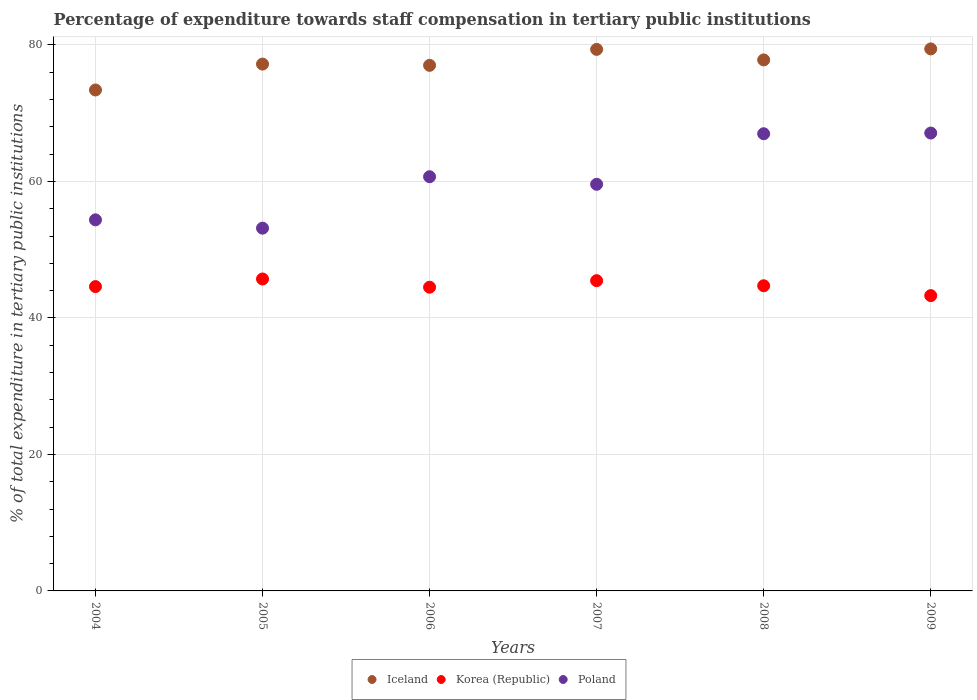How many different coloured dotlines are there?
Make the answer very short. 3. What is the percentage of expenditure towards staff compensation in Korea (Republic) in 2006?
Make the answer very short. 44.5. Across all years, what is the maximum percentage of expenditure towards staff compensation in Poland?
Give a very brief answer. 67.09. Across all years, what is the minimum percentage of expenditure towards staff compensation in Poland?
Your response must be concise. 53.15. In which year was the percentage of expenditure towards staff compensation in Korea (Republic) minimum?
Provide a succinct answer. 2009. What is the total percentage of expenditure towards staff compensation in Korea (Republic) in the graph?
Make the answer very short. 268.24. What is the difference between the percentage of expenditure towards staff compensation in Poland in 2005 and that in 2007?
Provide a short and direct response. -6.43. What is the difference between the percentage of expenditure towards staff compensation in Korea (Republic) in 2005 and the percentage of expenditure towards staff compensation in Poland in 2007?
Your answer should be very brief. -13.88. What is the average percentage of expenditure towards staff compensation in Poland per year?
Provide a short and direct response. 60.31. In the year 2009, what is the difference between the percentage of expenditure towards staff compensation in Iceland and percentage of expenditure towards staff compensation in Korea (Republic)?
Offer a very short reply. 36.15. What is the ratio of the percentage of expenditure towards staff compensation in Iceland in 2004 to that in 2007?
Provide a short and direct response. 0.93. What is the difference between the highest and the second highest percentage of expenditure towards staff compensation in Poland?
Offer a terse response. 0.1. What is the difference between the highest and the lowest percentage of expenditure towards staff compensation in Korea (Republic)?
Your answer should be very brief. 2.44. Is the percentage of expenditure towards staff compensation in Poland strictly greater than the percentage of expenditure towards staff compensation in Iceland over the years?
Provide a short and direct response. No. What is the difference between two consecutive major ticks on the Y-axis?
Offer a terse response. 20. Are the values on the major ticks of Y-axis written in scientific E-notation?
Your answer should be compact. No. Does the graph contain any zero values?
Provide a short and direct response. No. How are the legend labels stacked?
Give a very brief answer. Horizontal. What is the title of the graph?
Your response must be concise. Percentage of expenditure towards staff compensation in tertiary public institutions. Does "Slovenia" appear as one of the legend labels in the graph?
Your answer should be compact. No. What is the label or title of the X-axis?
Provide a short and direct response. Years. What is the label or title of the Y-axis?
Keep it short and to the point. % of total expenditure in tertiary public institutions. What is the % of total expenditure in tertiary public institutions of Iceland in 2004?
Give a very brief answer. 73.4. What is the % of total expenditure in tertiary public institutions in Korea (Republic) in 2004?
Make the answer very short. 44.59. What is the % of total expenditure in tertiary public institutions of Poland in 2004?
Give a very brief answer. 54.37. What is the % of total expenditure in tertiary public institutions of Iceland in 2005?
Offer a very short reply. 77.19. What is the % of total expenditure in tertiary public institutions of Korea (Republic) in 2005?
Provide a succinct answer. 45.71. What is the % of total expenditure in tertiary public institutions of Poland in 2005?
Your response must be concise. 53.15. What is the % of total expenditure in tertiary public institutions in Iceland in 2006?
Make the answer very short. 77.01. What is the % of total expenditure in tertiary public institutions in Korea (Republic) in 2006?
Offer a terse response. 44.5. What is the % of total expenditure in tertiary public institutions of Poland in 2006?
Give a very brief answer. 60.69. What is the % of total expenditure in tertiary public institutions of Iceland in 2007?
Provide a short and direct response. 79.35. What is the % of total expenditure in tertiary public institutions of Korea (Republic) in 2007?
Provide a short and direct response. 45.46. What is the % of total expenditure in tertiary public institutions in Poland in 2007?
Provide a short and direct response. 59.58. What is the % of total expenditure in tertiary public institutions of Iceland in 2008?
Provide a short and direct response. 77.8. What is the % of total expenditure in tertiary public institutions of Korea (Republic) in 2008?
Your answer should be very brief. 44.71. What is the % of total expenditure in tertiary public institutions in Poland in 2008?
Give a very brief answer. 66.99. What is the % of total expenditure in tertiary public institutions of Iceland in 2009?
Give a very brief answer. 79.42. What is the % of total expenditure in tertiary public institutions in Korea (Republic) in 2009?
Offer a very short reply. 43.27. What is the % of total expenditure in tertiary public institutions of Poland in 2009?
Offer a terse response. 67.09. Across all years, what is the maximum % of total expenditure in tertiary public institutions in Iceland?
Provide a succinct answer. 79.42. Across all years, what is the maximum % of total expenditure in tertiary public institutions of Korea (Republic)?
Keep it short and to the point. 45.71. Across all years, what is the maximum % of total expenditure in tertiary public institutions in Poland?
Offer a terse response. 67.09. Across all years, what is the minimum % of total expenditure in tertiary public institutions of Iceland?
Make the answer very short. 73.4. Across all years, what is the minimum % of total expenditure in tertiary public institutions in Korea (Republic)?
Ensure brevity in your answer.  43.27. Across all years, what is the minimum % of total expenditure in tertiary public institutions of Poland?
Make the answer very short. 53.15. What is the total % of total expenditure in tertiary public institutions of Iceland in the graph?
Provide a succinct answer. 464.17. What is the total % of total expenditure in tertiary public institutions of Korea (Republic) in the graph?
Your response must be concise. 268.24. What is the total % of total expenditure in tertiary public institutions of Poland in the graph?
Your answer should be very brief. 361.87. What is the difference between the % of total expenditure in tertiary public institutions of Iceland in 2004 and that in 2005?
Provide a succinct answer. -3.79. What is the difference between the % of total expenditure in tertiary public institutions in Korea (Republic) in 2004 and that in 2005?
Your answer should be compact. -1.11. What is the difference between the % of total expenditure in tertiary public institutions of Poland in 2004 and that in 2005?
Your answer should be very brief. 1.22. What is the difference between the % of total expenditure in tertiary public institutions of Iceland in 2004 and that in 2006?
Provide a short and direct response. -3.61. What is the difference between the % of total expenditure in tertiary public institutions in Korea (Republic) in 2004 and that in 2006?
Offer a very short reply. 0.09. What is the difference between the % of total expenditure in tertiary public institutions in Poland in 2004 and that in 2006?
Offer a terse response. -6.32. What is the difference between the % of total expenditure in tertiary public institutions in Iceland in 2004 and that in 2007?
Your answer should be compact. -5.95. What is the difference between the % of total expenditure in tertiary public institutions of Korea (Republic) in 2004 and that in 2007?
Provide a succinct answer. -0.87. What is the difference between the % of total expenditure in tertiary public institutions in Poland in 2004 and that in 2007?
Make the answer very short. -5.21. What is the difference between the % of total expenditure in tertiary public institutions in Iceland in 2004 and that in 2008?
Make the answer very short. -4.41. What is the difference between the % of total expenditure in tertiary public institutions in Korea (Republic) in 2004 and that in 2008?
Your answer should be compact. -0.12. What is the difference between the % of total expenditure in tertiary public institutions in Poland in 2004 and that in 2008?
Your answer should be very brief. -12.61. What is the difference between the % of total expenditure in tertiary public institutions of Iceland in 2004 and that in 2009?
Your response must be concise. -6.02. What is the difference between the % of total expenditure in tertiary public institutions of Korea (Republic) in 2004 and that in 2009?
Your response must be concise. 1.32. What is the difference between the % of total expenditure in tertiary public institutions of Poland in 2004 and that in 2009?
Keep it short and to the point. -12.72. What is the difference between the % of total expenditure in tertiary public institutions of Iceland in 2005 and that in 2006?
Ensure brevity in your answer.  0.18. What is the difference between the % of total expenditure in tertiary public institutions of Korea (Republic) in 2005 and that in 2006?
Offer a terse response. 1.21. What is the difference between the % of total expenditure in tertiary public institutions of Poland in 2005 and that in 2006?
Provide a short and direct response. -7.54. What is the difference between the % of total expenditure in tertiary public institutions in Iceland in 2005 and that in 2007?
Offer a terse response. -2.16. What is the difference between the % of total expenditure in tertiary public institutions in Korea (Republic) in 2005 and that in 2007?
Your answer should be compact. 0.25. What is the difference between the % of total expenditure in tertiary public institutions of Poland in 2005 and that in 2007?
Your response must be concise. -6.43. What is the difference between the % of total expenditure in tertiary public institutions in Iceland in 2005 and that in 2008?
Keep it short and to the point. -0.61. What is the difference between the % of total expenditure in tertiary public institutions of Poland in 2005 and that in 2008?
Make the answer very short. -13.83. What is the difference between the % of total expenditure in tertiary public institutions of Iceland in 2005 and that in 2009?
Your answer should be very brief. -2.22. What is the difference between the % of total expenditure in tertiary public institutions in Korea (Republic) in 2005 and that in 2009?
Ensure brevity in your answer.  2.44. What is the difference between the % of total expenditure in tertiary public institutions of Poland in 2005 and that in 2009?
Offer a terse response. -13.94. What is the difference between the % of total expenditure in tertiary public institutions in Iceland in 2006 and that in 2007?
Your answer should be very brief. -2.34. What is the difference between the % of total expenditure in tertiary public institutions of Korea (Republic) in 2006 and that in 2007?
Provide a succinct answer. -0.96. What is the difference between the % of total expenditure in tertiary public institutions in Poland in 2006 and that in 2007?
Offer a very short reply. 1.11. What is the difference between the % of total expenditure in tertiary public institutions in Iceland in 2006 and that in 2008?
Ensure brevity in your answer.  -0.79. What is the difference between the % of total expenditure in tertiary public institutions of Korea (Republic) in 2006 and that in 2008?
Ensure brevity in your answer.  -0.21. What is the difference between the % of total expenditure in tertiary public institutions in Poland in 2006 and that in 2008?
Your response must be concise. -6.3. What is the difference between the % of total expenditure in tertiary public institutions of Iceland in 2006 and that in 2009?
Give a very brief answer. -2.41. What is the difference between the % of total expenditure in tertiary public institutions in Korea (Republic) in 2006 and that in 2009?
Your response must be concise. 1.23. What is the difference between the % of total expenditure in tertiary public institutions in Poland in 2006 and that in 2009?
Offer a very short reply. -6.4. What is the difference between the % of total expenditure in tertiary public institutions of Iceland in 2007 and that in 2008?
Your answer should be very brief. 1.54. What is the difference between the % of total expenditure in tertiary public institutions in Korea (Republic) in 2007 and that in 2008?
Give a very brief answer. 0.75. What is the difference between the % of total expenditure in tertiary public institutions of Poland in 2007 and that in 2008?
Make the answer very short. -7.41. What is the difference between the % of total expenditure in tertiary public institutions in Iceland in 2007 and that in 2009?
Your answer should be compact. -0.07. What is the difference between the % of total expenditure in tertiary public institutions of Korea (Republic) in 2007 and that in 2009?
Make the answer very short. 2.19. What is the difference between the % of total expenditure in tertiary public institutions in Poland in 2007 and that in 2009?
Offer a terse response. -7.51. What is the difference between the % of total expenditure in tertiary public institutions in Iceland in 2008 and that in 2009?
Keep it short and to the point. -1.61. What is the difference between the % of total expenditure in tertiary public institutions of Korea (Republic) in 2008 and that in 2009?
Your answer should be compact. 1.44. What is the difference between the % of total expenditure in tertiary public institutions of Poland in 2008 and that in 2009?
Your response must be concise. -0.1. What is the difference between the % of total expenditure in tertiary public institutions of Iceland in 2004 and the % of total expenditure in tertiary public institutions of Korea (Republic) in 2005?
Ensure brevity in your answer.  27.69. What is the difference between the % of total expenditure in tertiary public institutions of Iceland in 2004 and the % of total expenditure in tertiary public institutions of Poland in 2005?
Your answer should be compact. 20.25. What is the difference between the % of total expenditure in tertiary public institutions of Korea (Republic) in 2004 and the % of total expenditure in tertiary public institutions of Poland in 2005?
Offer a terse response. -8.56. What is the difference between the % of total expenditure in tertiary public institutions of Iceland in 2004 and the % of total expenditure in tertiary public institutions of Korea (Republic) in 2006?
Offer a very short reply. 28.9. What is the difference between the % of total expenditure in tertiary public institutions of Iceland in 2004 and the % of total expenditure in tertiary public institutions of Poland in 2006?
Provide a succinct answer. 12.71. What is the difference between the % of total expenditure in tertiary public institutions in Korea (Republic) in 2004 and the % of total expenditure in tertiary public institutions in Poland in 2006?
Your answer should be compact. -16.1. What is the difference between the % of total expenditure in tertiary public institutions in Iceland in 2004 and the % of total expenditure in tertiary public institutions in Korea (Republic) in 2007?
Your answer should be compact. 27.94. What is the difference between the % of total expenditure in tertiary public institutions of Iceland in 2004 and the % of total expenditure in tertiary public institutions of Poland in 2007?
Your answer should be compact. 13.82. What is the difference between the % of total expenditure in tertiary public institutions of Korea (Republic) in 2004 and the % of total expenditure in tertiary public institutions of Poland in 2007?
Your answer should be compact. -14.99. What is the difference between the % of total expenditure in tertiary public institutions of Iceland in 2004 and the % of total expenditure in tertiary public institutions of Korea (Republic) in 2008?
Provide a succinct answer. 28.69. What is the difference between the % of total expenditure in tertiary public institutions in Iceland in 2004 and the % of total expenditure in tertiary public institutions in Poland in 2008?
Your answer should be compact. 6.41. What is the difference between the % of total expenditure in tertiary public institutions in Korea (Republic) in 2004 and the % of total expenditure in tertiary public institutions in Poland in 2008?
Provide a succinct answer. -22.39. What is the difference between the % of total expenditure in tertiary public institutions in Iceland in 2004 and the % of total expenditure in tertiary public institutions in Korea (Republic) in 2009?
Give a very brief answer. 30.13. What is the difference between the % of total expenditure in tertiary public institutions in Iceland in 2004 and the % of total expenditure in tertiary public institutions in Poland in 2009?
Provide a succinct answer. 6.31. What is the difference between the % of total expenditure in tertiary public institutions of Korea (Republic) in 2004 and the % of total expenditure in tertiary public institutions of Poland in 2009?
Provide a short and direct response. -22.5. What is the difference between the % of total expenditure in tertiary public institutions of Iceland in 2005 and the % of total expenditure in tertiary public institutions of Korea (Republic) in 2006?
Offer a terse response. 32.69. What is the difference between the % of total expenditure in tertiary public institutions of Iceland in 2005 and the % of total expenditure in tertiary public institutions of Poland in 2006?
Offer a very short reply. 16.5. What is the difference between the % of total expenditure in tertiary public institutions in Korea (Republic) in 2005 and the % of total expenditure in tertiary public institutions in Poland in 2006?
Offer a very short reply. -14.98. What is the difference between the % of total expenditure in tertiary public institutions of Iceland in 2005 and the % of total expenditure in tertiary public institutions of Korea (Republic) in 2007?
Your answer should be compact. 31.73. What is the difference between the % of total expenditure in tertiary public institutions in Iceland in 2005 and the % of total expenditure in tertiary public institutions in Poland in 2007?
Give a very brief answer. 17.61. What is the difference between the % of total expenditure in tertiary public institutions in Korea (Republic) in 2005 and the % of total expenditure in tertiary public institutions in Poland in 2007?
Your answer should be very brief. -13.88. What is the difference between the % of total expenditure in tertiary public institutions of Iceland in 2005 and the % of total expenditure in tertiary public institutions of Korea (Republic) in 2008?
Your answer should be very brief. 32.48. What is the difference between the % of total expenditure in tertiary public institutions in Iceland in 2005 and the % of total expenditure in tertiary public institutions in Poland in 2008?
Your response must be concise. 10.21. What is the difference between the % of total expenditure in tertiary public institutions in Korea (Republic) in 2005 and the % of total expenditure in tertiary public institutions in Poland in 2008?
Provide a succinct answer. -21.28. What is the difference between the % of total expenditure in tertiary public institutions of Iceland in 2005 and the % of total expenditure in tertiary public institutions of Korea (Republic) in 2009?
Keep it short and to the point. 33.92. What is the difference between the % of total expenditure in tertiary public institutions of Iceland in 2005 and the % of total expenditure in tertiary public institutions of Poland in 2009?
Your answer should be compact. 10.1. What is the difference between the % of total expenditure in tertiary public institutions in Korea (Republic) in 2005 and the % of total expenditure in tertiary public institutions in Poland in 2009?
Keep it short and to the point. -21.38. What is the difference between the % of total expenditure in tertiary public institutions of Iceland in 2006 and the % of total expenditure in tertiary public institutions of Korea (Republic) in 2007?
Your answer should be very brief. 31.55. What is the difference between the % of total expenditure in tertiary public institutions in Iceland in 2006 and the % of total expenditure in tertiary public institutions in Poland in 2007?
Your response must be concise. 17.43. What is the difference between the % of total expenditure in tertiary public institutions in Korea (Republic) in 2006 and the % of total expenditure in tertiary public institutions in Poland in 2007?
Keep it short and to the point. -15.08. What is the difference between the % of total expenditure in tertiary public institutions of Iceland in 2006 and the % of total expenditure in tertiary public institutions of Korea (Republic) in 2008?
Provide a short and direct response. 32.3. What is the difference between the % of total expenditure in tertiary public institutions of Iceland in 2006 and the % of total expenditure in tertiary public institutions of Poland in 2008?
Your answer should be very brief. 10.02. What is the difference between the % of total expenditure in tertiary public institutions of Korea (Republic) in 2006 and the % of total expenditure in tertiary public institutions of Poland in 2008?
Give a very brief answer. -22.49. What is the difference between the % of total expenditure in tertiary public institutions of Iceland in 2006 and the % of total expenditure in tertiary public institutions of Korea (Republic) in 2009?
Make the answer very short. 33.74. What is the difference between the % of total expenditure in tertiary public institutions of Iceland in 2006 and the % of total expenditure in tertiary public institutions of Poland in 2009?
Make the answer very short. 9.92. What is the difference between the % of total expenditure in tertiary public institutions in Korea (Republic) in 2006 and the % of total expenditure in tertiary public institutions in Poland in 2009?
Provide a short and direct response. -22.59. What is the difference between the % of total expenditure in tertiary public institutions in Iceland in 2007 and the % of total expenditure in tertiary public institutions in Korea (Republic) in 2008?
Ensure brevity in your answer.  34.64. What is the difference between the % of total expenditure in tertiary public institutions in Iceland in 2007 and the % of total expenditure in tertiary public institutions in Poland in 2008?
Your answer should be compact. 12.36. What is the difference between the % of total expenditure in tertiary public institutions in Korea (Republic) in 2007 and the % of total expenditure in tertiary public institutions in Poland in 2008?
Give a very brief answer. -21.53. What is the difference between the % of total expenditure in tertiary public institutions in Iceland in 2007 and the % of total expenditure in tertiary public institutions in Korea (Republic) in 2009?
Keep it short and to the point. 36.08. What is the difference between the % of total expenditure in tertiary public institutions in Iceland in 2007 and the % of total expenditure in tertiary public institutions in Poland in 2009?
Make the answer very short. 12.26. What is the difference between the % of total expenditure in tertiary public institutions in Korea (Republic) in 2007 and the % of total expenditure in tertiary public institutions in Poland in 2009?
Provide a succinct answer. -21.63. What is the difference between the % of total expenditure in tertiary public institutions in Iceland in 2008 and the % of total expenditure in tertiary public institutions in Korea (Republic) in 2009?
Your answer should be compact. 34.54. What is the difference between the % of total expenditure in tertiary public institutions in Iceland in 2008 and the % of total expenditure in tertiary public institutions in Poland in 2009?
Make the answer very short. 10.72. What is the difference between the % of total expenditure in tertiary public institutions of Korea (Republic) in 2008 and the % of total expenditure in tertiary public institutions of Poland in 2009?
Your response must be concise. -22.38. What is the average % of total expenditure in tertiary public institutions in Iceland per year?
Your answer should be very brief. 77.36. What is the average % of total expenditure in tertiary public institutions in Korea (Republic) per year?
Give a very brief answer. 44.71. What is the average % of total expenditure in tertiary public institutions of Poland per year?
Offer a very short reply. 60.31. In the year 2004, what is the difference between the % of total expenditure in tertiary public institutions in Iceland and % of total expenditure in tertiary public institutions in Korea (Republic)?
Provide a short and direct response. 28.81. In the year 2004, what is the difference between the % of total expenditure in tertiary public institutions in Iceland and % of total expenditure in tertiary public institutions in Poland?
Provide a short and direct response. 19.03. In the year 2004, what is the difference between the % of total expenditure in tertiary public institutions in Korea (Republic) and % of total expenditure in tertiary public institutions in Poland?
Offer a very short reply. -9.78. In the year 2005, what is the difference between the % of total expenditure in tertiary public institutions in Iceland and % of total expenditure in tertiary public institutions in Korea (Republic)?
Provide a short and direct response. 31.49. In the year 2005, what is the difference between the % of total expenditure in tertiary public institutions in Iceland and % of total expenditure in tertiary public institutions in Poland?
Keep it short and to the point. 24.04. In the year 2005, what is the difference between the % of total expenditure in tertiary public institutions in Korea (Republic) and % of total expenditure in tertiary public institutions in Poland?
Provide a short and direct response. -7.45. In the year 2006, what is the difference between the % of total expenditure in tertiary public institutions of Iceland and % of total expenditure in tertiary public institutions of Korea (Republic)?
Ensure brevity in your answer.  32.51. In the year 2006, what is the difference between the % of total expenditure in tertiary public institutions of Iceland and % of total expenditure in tertiary public institutions of Poland?
Provide a succinct answer. 16.32. In the year 2006, what is the difference between the % of total expenditure in tertiary public institutions of Korea (Republic) and % of total expenditure in tertiary public institutions of Poland?
Provide a short and direct response. -16.19. In the year 2007, what is the difference between the % of total expenditure in tertiary public institutions of Iceland and % of total expenditure in tertiary public institutions of Korea (Republic)?
Offer a very short reply. 33.89. In the year 2007, what is the difference between the % of total expenditure in tertiary public institutions of Iceland and % of total expenditure in tertiary public institutions of Poland?
Provide a succinct answer. 19.77. In the year 2007, what is the difference between the % of total expenditure in tertiary public institutions in Korea (Republic) and % of total expenditure in tertiary public institutions in Poland?
Keep it short and to the point. -14.12. In the year 2008, what is the difference between the % of total expenditure in tertiary public institutions of Iceland and % of total expenditure in tertiary public institutions of Korea (Republic)?
Offer a very short reply. 33.09. In the year 2008, what is the difference between the % of total expenditure in tertiary public institutions of Iceland and % of total expenditure in tertiary public institutions of Poland?
Your answer should be very brief. 10.82. In the year 2008, what is the difference between the % of total expenditure in tertiary public institutions of Korea (Republic) and % of total expenditure in tertiary public institutions of Poland?
Your answer should be compact. -22.27. In the year 2009, what is the difference between the % of total expenditure in tertiary public institutions in Iceland and % of total expenditure in tertiary public institutions in Korea (Republic)?
Give a very brief answer. 36.15. In the year 2009, what is the difference between the % of total expenditure in tertiary public institutions of Iceland and % of total expenditure in tertiary public institutions of Poland?
Provide a succinct answer. 12.33. In the year 2009, what is the difference between the % of total expenditure in tertiary public institutions in Korea (Republic) and % of total expenditure in tertiary public institutions in Poland?
Offer a terse response. -23.82. What is the ratio of the % of total expenditure in tertiary public institutions of Iceland in 2004 to that in 2005?
Your answer should be compact. 0.95. What is the ratio of the % of total expenditure in tertiary public institutions of Korea (Republic) in 2004 to that in 2005?
Make the answer very short. 0.98. What is the ratio of the % of total expenditure in tertiary public institutions in Poland in 2004 to that in 2005?
Give a very brief answer. 1.02. What is the ratio of the % of total expenditure in tertiary public institutions in Iceland in 2004 to that in 2006?
Your answer should be compact. 0.95. What is the ratio of the % of total expenditure in tertiary public institutions in Korea (Republic) in 2004 to that in 2006?
Give a very brief answer. 1. What is the ratio of the % of total expenditure in tertiary public institutions in Poland in 2004 to that in 2006?
Give a very brief answer. 0.9. What is the ratio of the % of total expenditure in tertiary public institutions of Iceland in 2004 to that in 2007?
Your answer should be very brief. 0.93. What is the ratio of the % of total expenditure in tertiary public institutions in Korea (Republic) in 2004 to that in 2007?
Provide a succinct answer. 0.98. What is the ratio of the % of total expenditure in tertiary public institutions in Poland in 2004 to that in 2007?
Keep it short and to the point. 0.91. What is the ratio of the % of total expenditure in tertiary public institutions in Iceland in 2004 to that in 2008?
Offer a terse response. 0.94. What is the ratio of the % of total expenditure in tertiary public institutions in Poland in 2004 to that in 2008?
Your answer should be very brief. 0.81. What is the ratio of the % of total expenditure in tertiary public institutions of Iceland in 2004 to that in 2009?
Make the answer very short. 0.92. What is the ratio of the % of total expenditure in tertiary public institutions of Korea (Republic) in 2004 to that in 2009?
Offer a very short reply. 1.03. What is the ratio of the % of total expenditure in tertiary public institutions in Poland in 2004 to that in 2009?
Ensure brevity in your answer.  0.81. What is the ratio of the % of total expenditure in tertiary public institutions of Korea (Republic) in 2005 to that in 2006?
Your response must be concise. 1.03. What is the ratio of the % of total expenditure in tertiary public institutions in Poland in 2005 to that in 2006?
Provide a short and direct response. 0.88. What is the ratio of the % of total expenditure in tertiary public institutions in Iceland in 2005 to that in 2007?
Ensure brevity in your answer.  0.97. What is the ratio of the % of total expenditure in tertiary public institutions in Korea (Republic) in 2005 to that in 2007?
Your answer should be very brief. 1.01. What is the ratio of the % of total expenditure in tertiary public institutions in Poland in 2005 to that in 2007?
Ensure brevity in your answer.  0.89. What is the ratio of the % of total expenditure in tertiary public institutions of Korea (Republic) in 2005 to that in 2008?
Give a very brief answer. 1.02. What is the ratio of the % of total expenditure in tertiary public institutions in Poland in 2005 to that in 2008?
Your response must be concise. 0.79. What is the ratio of the % of total expenditure in tertiary public institutions in Iceland in 2005 to that in 2009?
Offer a terse response. 0.97. What is the ratio of the % of total expenditure in tertiary public institutions of Korea (Republic) in 2005 to that in 2009?
Provide a succinct answer. 1.06. What is the ratio of the % of total expenditure in tertiary public institutions of Poland in 2005 to that in 2009?
Your response must be concise. 0.79. What is the ratio of the % of total expenditure in tertiary public institutions of Iceland in 2006 to that in 2007?
Your answer should be compact. 0.97. What is the ratio of the % of total expenditure in tertiary public institutions in Korea (Republic) in 2006 to that in 2007?
Offer a terse response. 0.98. What is the ratio of the % of total expenditure in tertiary public institutions of Poland in 2006 to that in 2007?
Keep it short and to the point. 1.02. What is the ratio of the % of total expenditure in tertiary public institutions in Iceland in 2006 to that in 2008?
Keep it short and to the point. 0.99. What is the ratio of the % of total expenditure in tertiary public institutions in Korea (Republic) in 2006 to that in 2008?
Ensure brevity in your answer.  1. What is the ratio of the % of total expenditure in tertiary public institutions in Poland in 2006 to that in 2008?
Make the answer very short. 0.91. What is the ratio of the % of total expenditure in tertiary public institutions in Iceland in 2006 to that in 2009?
Offer a very short reply. 0.97. What is the ratio of the % of total expenditure in tertiary public institutions of Korea (Republic) in 2006 to that in 2009?
Your answer should be compact. 1.03. What is the ratio of the % of total expenditure in tertiary public institutions in Poland in 2006 to that in 2009?
Ensure brevity in your answer.  0.9. What is the ratio of the % of total expenditure in tertiary public institutions of Iceland in 2007 to that in 2008?
Your answer should be very brief. 1.02. What is the ratio of the % of total expenditure in tertiary public institutions in Korea (Republic) in 2007 to that in 2008?
Provide a short and direct response. 1.02. What is the ratio of the % of total expenditure in tertiary public institutions of Poland in 2007 to that in 2008?
Keep it short and to the point. 0.89. What is the ratio of the % of total expenditure in tertiary public institutions of Iceland in 2007 to that in 2009?
Provide a succinct answer. 1. What is the ratio of the % of total expenditure in tertiary public institutions in Korea (Republic) in 2007 to that in 2009?
Provide a succinct answer. 1.05. What is the ratio of the % of total expenditure in tertiary public institutions of Poland in 2007 to that in 2009?
Your response must be concise. 0.89. What is the ratio of the % of total expenditure in tertiary public institutions of Iceland in 2008 to that in 2009?
Ensure brevity in your answer.  0.98. What is the ratio of the % of total expenditure in tertiary public institutions of Korea (Republic) in 2008 to that in 2009?
Give a very brief answer. 1.03. What is the ratio of the % of total expenditure in tertiary public institutions in Poland in 2008 to that in 2009?
Your answer should be very brief. 1. What is the difference between the highest and the second highest % of total expenditure in tertiary public institutions of Iceland?
Your response must be concise. 0.07. What is the difference between the highest and the second highest % of total expenditure in tertiary public institutions in Korea (Republic)?
Give a very brief answer. 0.25. What is the difference between the highest and the second highest % of total expenditure in tertiary public institutions in Poland?
Offer a terse response. 0.1. What is the difference between the highest and the lowest % of total expenditure in tertiary public institutions in Iceland?
Make the answer very short. 6.02. What is the difference between the highest and the lowest % of total expenditure in tertiary public institutions of Korea (Republic)?
Offer a terse response. 2.44. What is the difference between the highest and the lowest % of total expenditure in tertiary public institutions of Poland?
Your response must be concise. 13.94. 